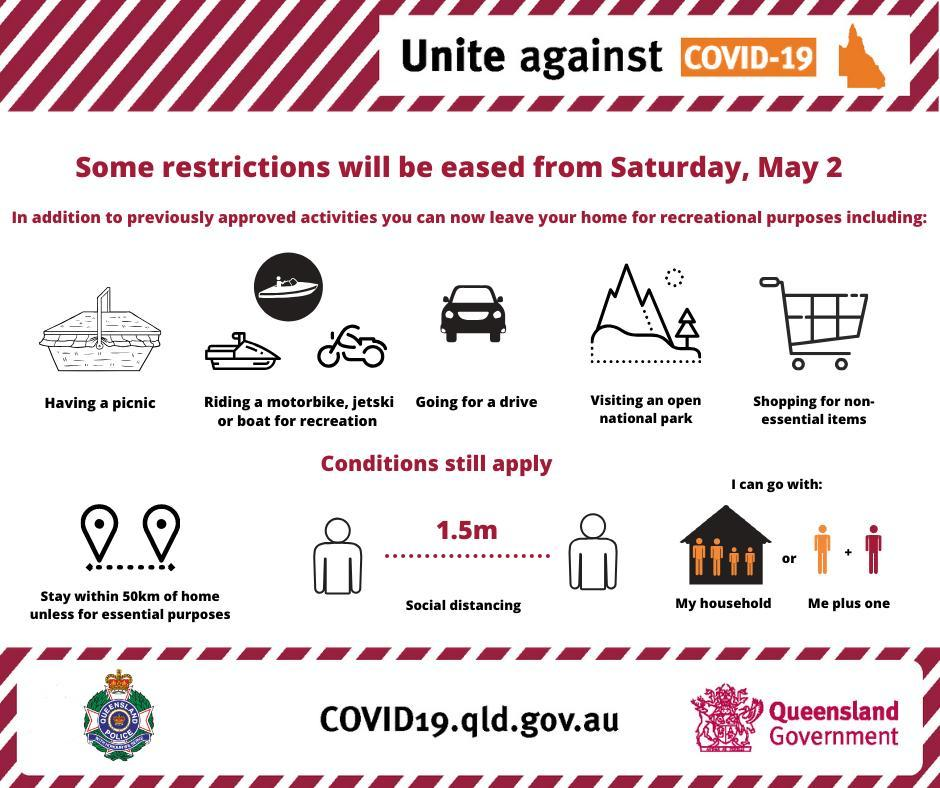How many conditions still apply?
Answer the question with a short phrase. 3 How many recreational purposes are in this infographic? 5 